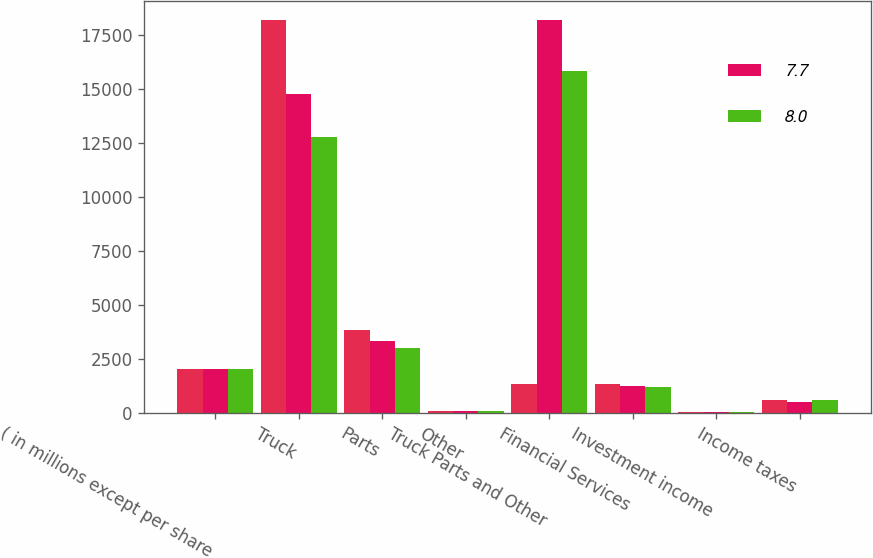Convert chart to OTSL. <chart><loc_0><loc_0><loc_500><loc_500><stacked_bar_chart><ecel><fcel>( in millions except per share<fcel>Truck<fcel>Parts<fcel>Other<fcel>Truck Parts and Other<fcel>Financial Services<fcel>Investment income<fcel>Income taxes<nl><fcel>nan<fcel>2018<fcel>18187<fcel>3838.9<fcel>112.7<fcel>1357.1<fcel>1357.1<fcel>60.9<fcel>615.1<nl><fcel>7.7<fcel>2017<fcel>14774.8<fcel>3327<fcel>85.7<fcel>18187.5<fcel>1268.9<fcel>35.3<fcel>498.1<nl><fcel>8<fcel>2016<fcel>12767.3<fcel>3005.7<fcel>73.6<fcel>15846.6<fcel>1186.7<fcel>27.6<fcel>608.7<nl></chart> 